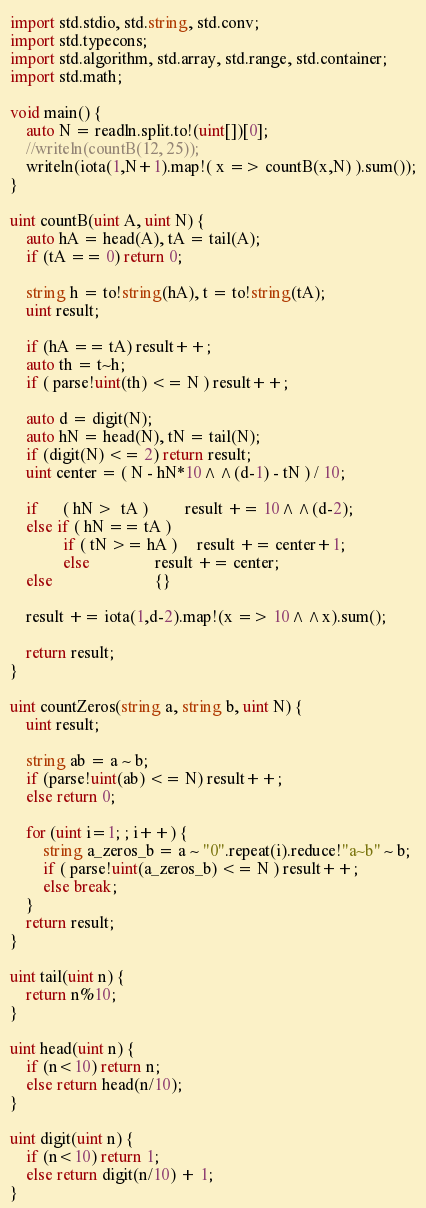Convert code to text. <code><loc_0><loc_0><loc_500><loc_500><_D_>import std.stdio, std.string, std.conv;
import std.typecons;
import std.algorithm, std.array, std.range, std.container;
import std.math;

void main() {
    auto N = readln.split.to!(uint[])[0];
    //writeln(countB(12, 25));
    writeln(iota(1,N+1).map!( x => countB(x,N) ).sum());
}

uint countB(uint A, uint N) {
    auto hA = head(A), tA = tail(A);
    if (tA == 0) return 0;
    
    string h = to!string(hA), t = to!string(tA);
    uint result;
    
    if (hA == tA) result++;
    auto th = t~h;
    if ( parse!uint(th) <= N ) result++;
    
    auto d = digit(N);
    auto hN = head(N), tN = tail(N);
    if (digit(N) <= 2) return result;
    uint center = ( N - hN*10^^(d-1) - tN ) / 10;
    
    if      ( hN >  tA )         result += 10^^(d-2);
    else if ( hN == tA )
             if ( tN >= hA )     result += center+1;
             else                result += center;
    else                         {}
    
    result += iota(1,d-2).map!(x => 10^^x).sum();
    
    return result;
}

uint countZeros(string a, string b, uint N) {
    uint result;
    
    string ab = a ~ b;
    if (parse!uint(ab) <= N) result++;
    else return 0;
    
    for (uint i=1; ; i++) {
        string a_zeros_b = a ~ "0".repeat(i).reduce!"a~b" ~ b;
        if ( parse!uint(a_zeros_b) <= N ) result++;
        else break;
    }
    return result;
}

uint tail(uint n) {
    return n%10;
}

uint head(uint n) {
    if (n<10) return n;
    else return head(n/10);
}

uint digit(uint n) {
    if (n<10) return 1;
    else return digit(n/10) + 1;
}</code> 